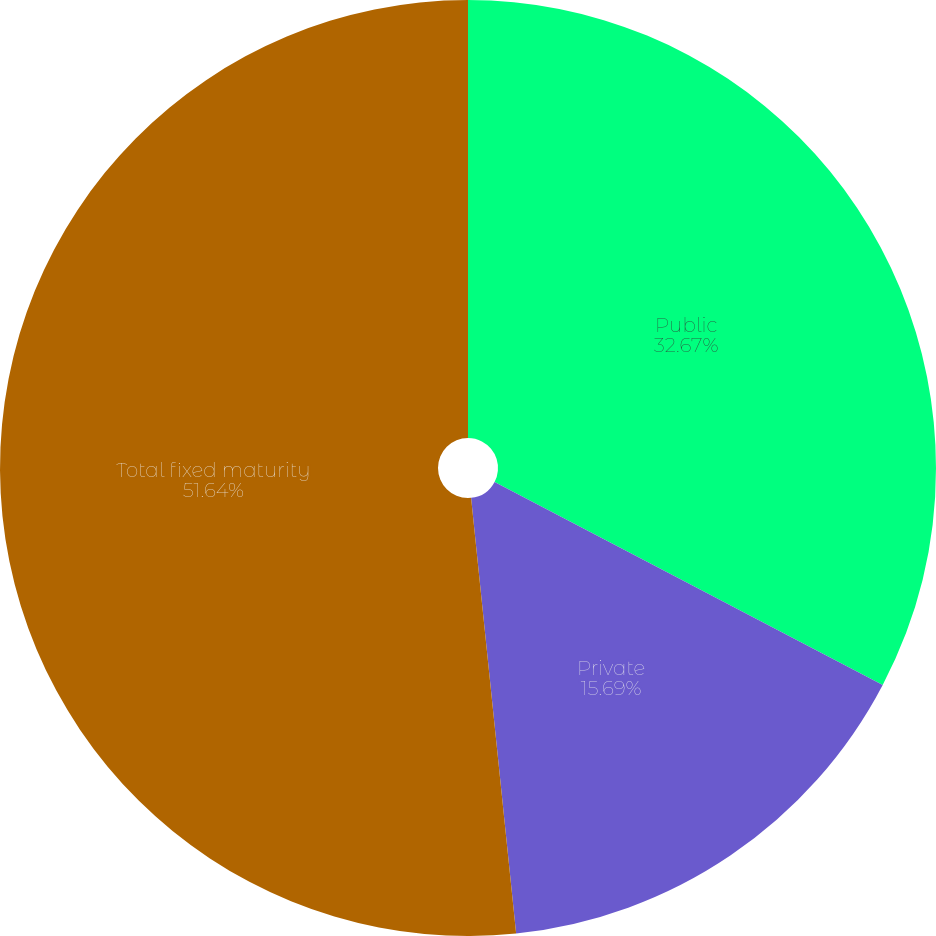Convert chart to OTSL. <chart><loc_0><loc_0><loc_500><loc_500><pie_chart><fcel>Public<fcel>Private<fcel>Total fixed maturity<nl><fcel>32.67%<fcel>15.69%<fcel>51.64%<nl></chart> 